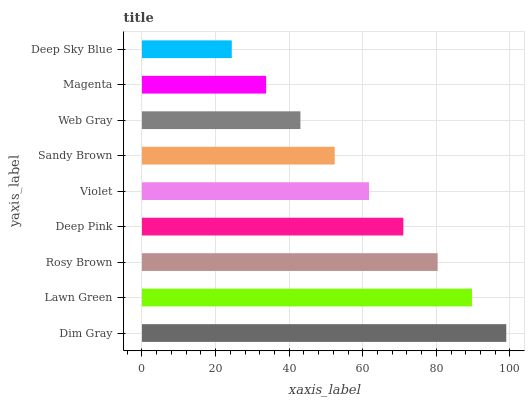Is Deep Sky Blue the minimum?
Answer yes or no. Yes. Is Dim Gray the maximum?
Answer yes or no. Yes. Is Lawn Green the minimum?
Answer yes or no. No. Is Lawn Green the maximum?
Answer yes or no. No. Is Dim Gray greater than Lawn Green?
Answer yes or no. Yes. Is Lawn Green less than Dim Gray?
Answer yes or no. Yes. Is Lawn Green greater than Dim Gray?
Answer yes or no. No. Is Dim Gray less than Lawn Green?
Answer yes or no. No. Is Violet the high median?
Answer yes or no. Yes. Is Violet the low median?
Answer yes or no. Yes. Is Sandy Brown the high median?
Answer yes or no. No. Is Deep Pink the low median?
Answer yes or no. No. 